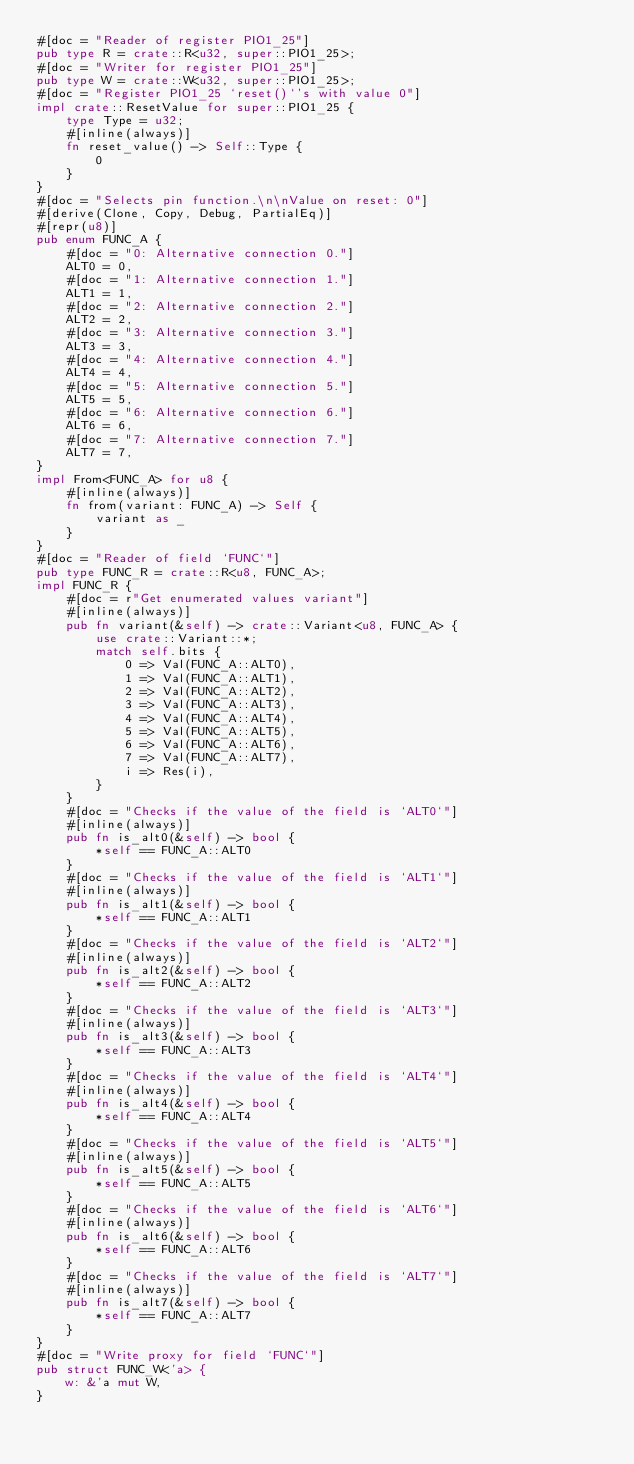Convert code to text. <code><loc_0><loc_0><loc_500><loc_500><_Rust_>#[doc = "Reader of register PIO1_25"]
pub type R = crate::R<u32, super::PIO1_25>;
#[doc = "Writer for register PIO1_25"]
pub type W = crate::W<u32, super::PIO1_25>;
#[doc = "Register PIO1_25 `reset()`'s with value 0"]
impl crate::ResetValue for super::PIO1_25 {
    type Type = u32;
    #[inline(always)]
    fn reset_value() -> Self::Type {
        0
    }
}
#[doc = "Selects pin function.\n\nValue on reset: 0"]
#[derive(Clone, Copy, Debug, PartialEq)]
#[repr(u8)]
pub enum FUNC_A {
    #[doc = "0: Alternative connection 0."]
    ALT0 = 0,
    #[doc = "1: Alternative connection 1."]
    ALT1 = 1,
    #[doc = "2: Alternative connection 2."]
    ALT2 = 2,
    #[doc = "3: Alternative connection 3."]
    ALT3 = 3,
    #[doc = "4: Alternative connection 4."]
    ALT4 = 4,
    #[doc = "5: Alternative connection 5."]
    ALT5 = 5,
    #[doc = "6: Alternative connection 6."]
    ALT6 = 6,
    #[doc = "7: Alternative connection 7."]
    ALT7 = 7,
}
impl From<FUNC_A> for u8 {
    #[inline(always)]
    fn from(variant: FUNC_A) -> Self {
        variant as _
    }
}
#[doc = "Reader of field `FUNC`"]
pub type FUNC_R = crate::R<u8, FUNC_A>;
impl FUNC_R {
    #[doc = r"Get enumerated values variant"]
    #[inline(always)]
    pub fn variant(&self) -> crate::Variant<u8, FUNC_A> {
        use crate::Variant::*;
        match self.bits {
            0 => Val(FUNC_A::ALT0),
            1 => Val(FUNC_A::ALT1),
            2 => Val(FUNC_A::ALT2),
            3 => Val(FUNC_A::ALT3),
            4 => Val(FUNC_A::ALT4),
            5 => Val(FUNC_A::ALT5),
            6 => Val(FUNC_A::ALT6),
            7 => Val(FUNC_A::ALT7),
            i => Res(i),
        }
    }
    #[doc = "Checks if the value of the field is `ALT0`"]
    #[inline(always)]
    pub fn is_alt0(&self) -> bool {
        *self == FUNC_A::ALT0
    }
    #[doc = "Checks if the value of the field is `ALT1`"]
    #[inline(always)]
    pub fn is_alt1(&self) -> bool {
        *self == FUNC_A::ALT1
    }
    #[doc = "Checks if the value of the field is `ALT2`"]
    #[inline(always)]
    pub fn is_alt2(&self) -> bool {
        *self == FUNC_A::ALT2
    }
    #[doc = "Checks if the value of the field is `ALT3`"]
    #[inline(always)]
    pub fn is_alt3(&self) -> bool {
        *self == FUNC_A::ALT3
    }
    #[doc = "Checks if the value of the field is `ALT4`"]
    #[inline(always)]
    pub fn is_alt4(&self) -> bool {
        *self == FUNC_A::ALT4
    }
    #[doc = "Checks if the value of the field is `ALT5`"]
    #[inline(always)]
    pub fn is_alt5(&self) -> bool {
        *self == FUNC_A::ALT5
    }
    #[doc = "Checks if the value of the field is `ALT6`"]
    #[inline(always)]
    pub fn is_alt6(&self) -> bool {
        *self == FUNC_A::ALT6
    }
    #[doc = "Checks if the value of the field is `ALT7`"]
    #[inline(always)]
    pub fn is_alt7(&self) -> bool {
        *self == FUNC_A::ALT7
    }
}
#[doc = "Write proxy for field `FUNC`"]
pub struct FUNC_W<'a> {
    w: &'a mut W,
}</code> 